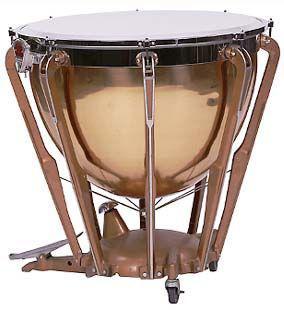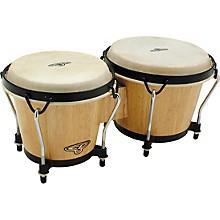The first image is the image on the left, the second image is the image on the right. Assess this claim about the two images: "there is at least one drum on a platform with wheels". Correct or not? Answer yes or no. Yes. The first image is the image on the left, the second image is the image on the right. Evaluate the accuracy of this statement regarding the images: "There are more drums in the image on the left.". Is it true? Answer yes or no. No. 